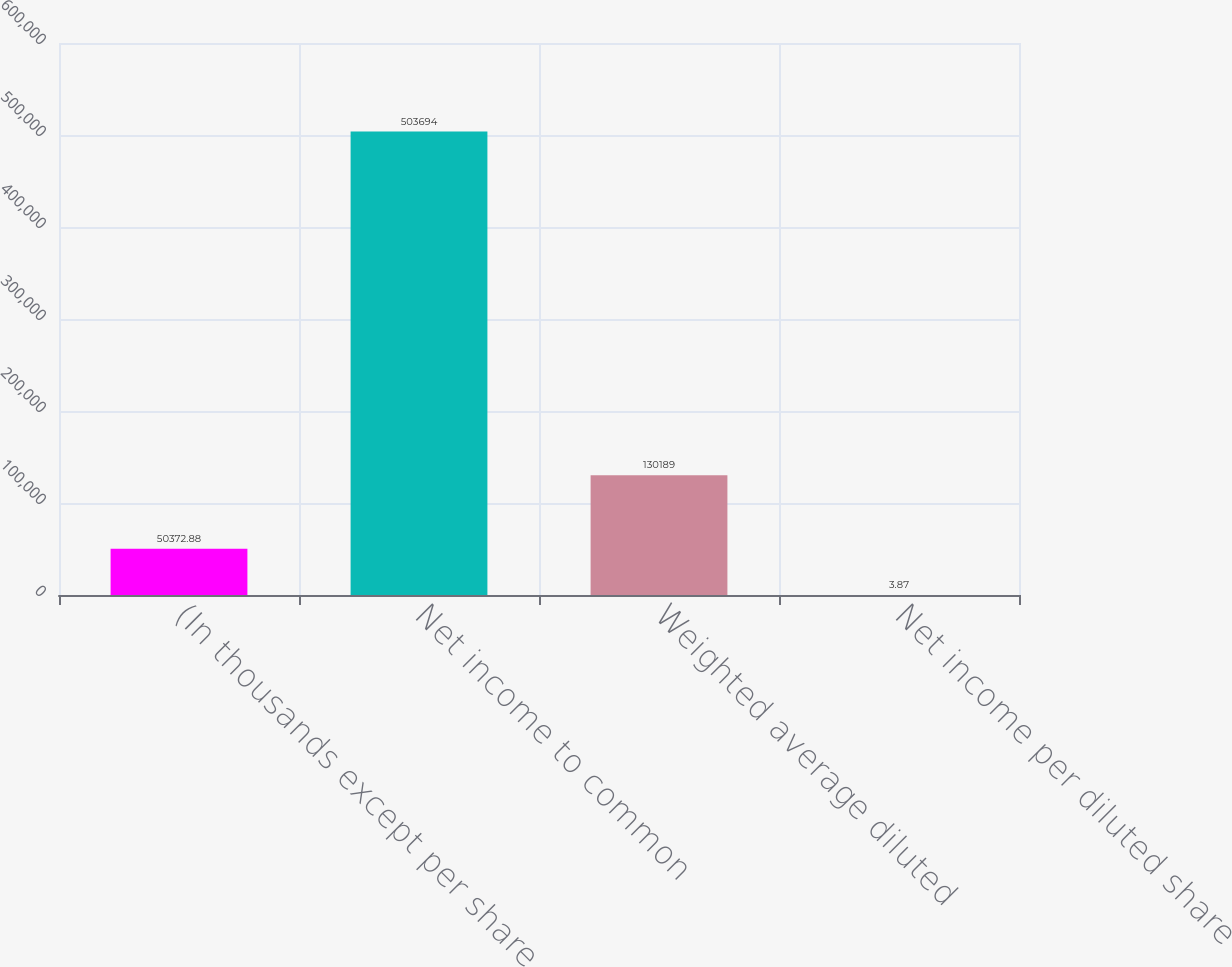<chart> <loc_0><loc_0><loc_500><loc_500><bar_chart><fcel>(In thousands except per share<fcel>Net income to common<fcel>Weighted average diluted<fcel>Net income per diluted share<nl><fcel>50372.9<fcel>503694<fcel>130189<fcel>3.87<nl></chart> 